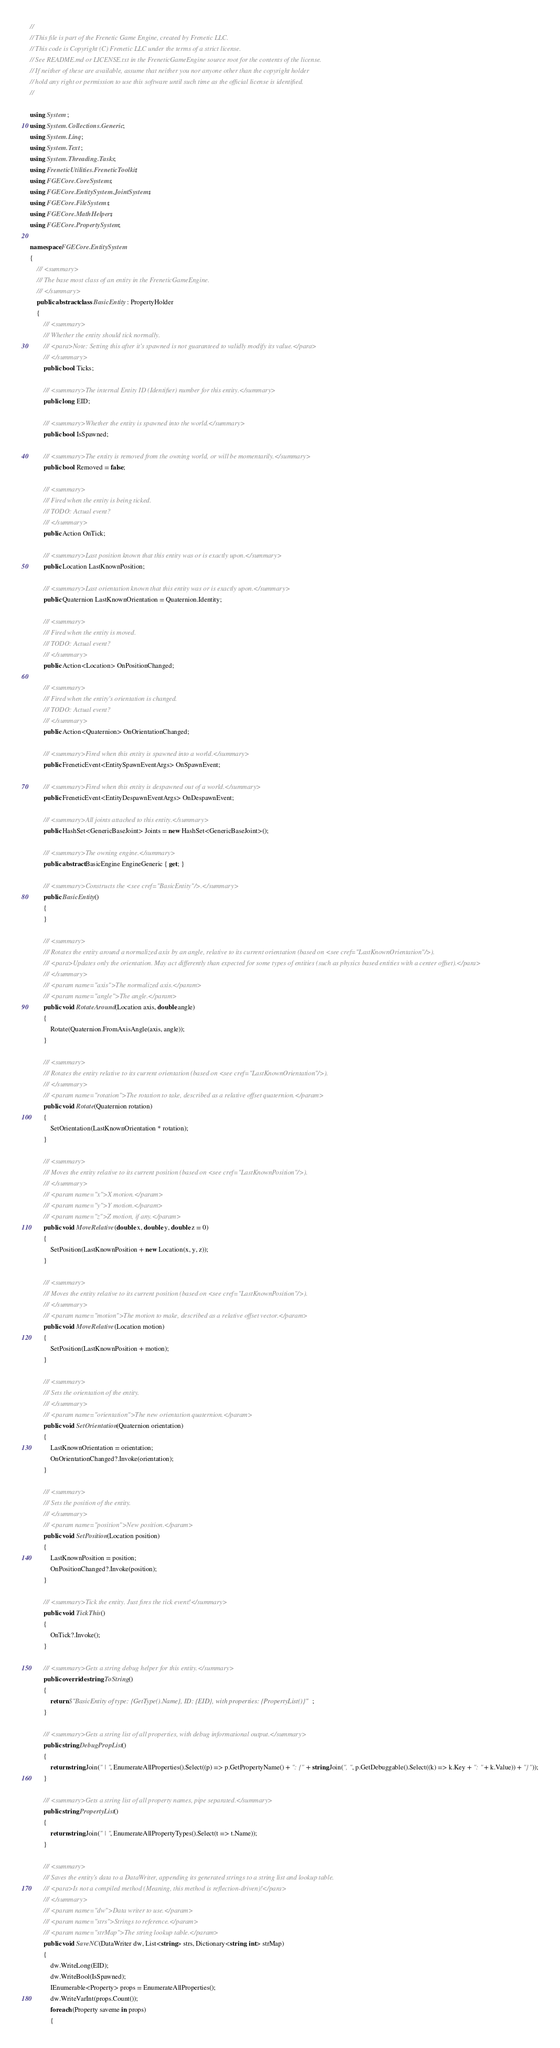Convert code to text. <code><loc_0><loc_0><loc_500><loc_500><_C#_>//
// This file is part of the Frenetic Game Engine, created by Frenetic LLC.
// This code is Copyright (C) Frenetic LLC under the terms of a strict license.
// See README.md or LICENSE.txt in the FreneticGameEngine source root for the contents of the license.
// If neither of these are available, assume that neither you nor anyone other than the copyright holder
// hold any right or permission to use this software until such time as the official license is identified.
//

using System;
using System.Collections.Generic;
using System.Linq;
using System.Text;
using System.Threading.Tasks;
using FreneticUtilities.FreneticToolkit;
using FGECore.CoreSystems;
using FGECore.EntitySystem.JointSystems;
using FGECore.FileSystems;
using FGECore.MathHelpers;
using FGECore.PropertySystem;

namespace FGECore.EntitySystem
{
    /// <summary>
    /// The base most class of an entity in the FreneticGameEngine.
    /// </summary>
    public abstract class BasicEntity : PropertyHolder
    {
        /// <summary>
        /// Whether the entity should tick normally.
        /// <para>Note: Setting this after it's spawned is not guaranteed to validly modify its value.</para>
        /// </summary>
        public bool Ticks;

        /// <summary>The internal Entity ID (Identifier) number for this entity.</summary>
        public long EID;

        /// <summary>Whether the entity is spawned into the world.</summary>
        public bool IsSpawned;

        /// <summary>The entity is removed from the owning world, or will be momentarily.</summary>
        public bool Removed = false;

        /// <summary>
        /// Fired when the entity is being ticked.
        /// TODO: Actual event?
        /// </summary>
        public Action OnTick;

        /// <summary>Last position known that this entity was or is exactly upon.</summary>
        public Location LastKnownPosition;

        /// <summary>Last orientation known that this entity was or is exactly upon.</summary>
        public Quaternion LastKnownOrientation = Quaternion.Identity;

        /// <summary>
        /// Fired when the entity is moved.
        /// TODO: Actual event?
        /// </summary>
        public Action<Location> OnPositionChanged;

        /// <summary>
        /// Fired when the entity's orientation is changed.
        /// TODO: Actual event?
        /// </summary>
        public Action<Quaternion> OnOrientationChanged;

        /// <summary>Fired when this entity is spawned into a world.</summary>
        public FreneticEvent<EntitySpawnEventArgs> OnSpawnEvent;

        /// <summary>Fired when this entity is despawned out of a world.</summary>
        public FreneticEvent<EntityDespawnEventArgs> OnDespawnEvent;

        /// <summary>All joints attached to this entity.</summary>
        public HashSet<GenericBaseJoint> Joints = new HashSet<GenericBaseJoint>();

        /// <summary>The owning engine.</summary>
        public abstract BasicEngine EngineGeneric { get; }

        /// <summary>Constructs the <see cref="BasicEntity"/>.</summary>
        public BasicEntity()
        {
        }

        /// <summary>
        /// Rotates the entity around a normalized axis by an angle, relative to its current orientation (based on <see cref="LastKnownOrientation"/>).
        /// <para>Updates only the orientation. May act differently than expected for some types of entities (such as physics based entities with a center offset).</para>
        /// </summary>
        /// <param name="axis">The normalized axis.</param>
        /// <param name="angle">The angle.</param>
        public void RotateAround(Location axis, double angle)
        {
            Rotate(Quaternion.FromAxisAngle(axis, angle));
        }

        /// <summary>
        /// Rotates the entity relative to its current orientation (based on <see cref="LastKnownOrientation"/>).
        /// </summary>
        /// <param name="rotation">The rotation to take, described as a relative offset quaternion.</param>
        public void Rotate(Quaternion rotation)
        {
            SetOrientation(LastKnownOrientation * rotation);
        }

        /// <summary>
        /// Moves the entity relative to its current position (based on <see cref="LastKnownPosition"/>).
        /// </summary>
        /// <param name="x">X motion.</param>
        /// <param name="y">Y motion.</param>
        /// <param name="z">Z motion, if any.</param>
        public void MoveRelative(double x, double y, double z = 0)
        {
            SetPosition(LastKnownPosition + new Location(x, y, z));
        }

        /// <summary>
        /// Moves the entity relative to its current position (based on <see cref="LastKnownPosition"/>).
        /// </summary>
        /// <param name="motion">The motion to make, described as a relative offset vector.</param>
        public void MoveRelative(Location motion)
        {
            SetPosition(LastKnownPosition + motion);
        }

        /// <summary>
        /// Sets the orientation of the entity.
        /// </summary>
        /// <param name="orientation">The new orientation quaternion.</param>
        public void SetOrientation(Quaternion orientation)
        {
            LastKnownOrientation = orientation;
            OnOrientationChanged?.Invoke(orientation);
        }

        /// <summary>
        /// Sets the position of the entity.
        /// </summary>
        /// <param name="position">New position.</param>
        public void SetPosition(Location position)
        {
            LastKnownPosition = position;
            OnPositionChanged?.Invoke(position);
        }

        /// <summary>Tick the entity. Just fires the tick event!</summary>
        public void TickThis()
        {
            OnTick?.Invoke();
        }

        /// <summary>Gets a string debug helper for this entity.</summary>
        public override string ToString()
        {
            return $"BasicEntity of type: {GetType().Name}, ID: {EID}, with properties: {PropertyList()}";
        }

        /// <summary>Gets a string list of all properties, with debug informational output.</summary>
        public string DebugPropList()
        {
            return string.Join(" | ", EnumerateAllProperties().Select((p) => p.GetPropertyName() + ": {" + string.Join(", ", p.GetDebuggable().Select((k) => k.Key + ": " + k.Value)) + "}"));
        }

        /// <summary>Gets a string list of all property names, pipe separated.</summary>
        public string PropertyList()
        {
            return string.Join(" | ", EnumerateAllPropertyTypes().Select(t => t.Name));
        }

        /// <summary>
        /// Saves the entity's data to a DataWriter, appending its generated strings to a string list and lookup table.
        /// <para>Is not a compiled method (Meaning, this method is reflection-driven)!</para>
        /// </summary>
        /// <param name="dw">Data writer to use.</param>
        /// <param name="strs">Strings to reference.</param>
        /// <param name="strMap">The string lookup table.</param>
        public void SaveNC(DataWriter dw, List<string> strs, Dictionary<string, int> strMap)
        {
            dw.WriteLong(EID);
            dw.WriteBool(IsSpawned);
            IEnumerable<Property> props = EnumerateAllProperties();
            dw.WriteVarInt(props.Count());
            foreach (Property saveme in props)
            {</code> 